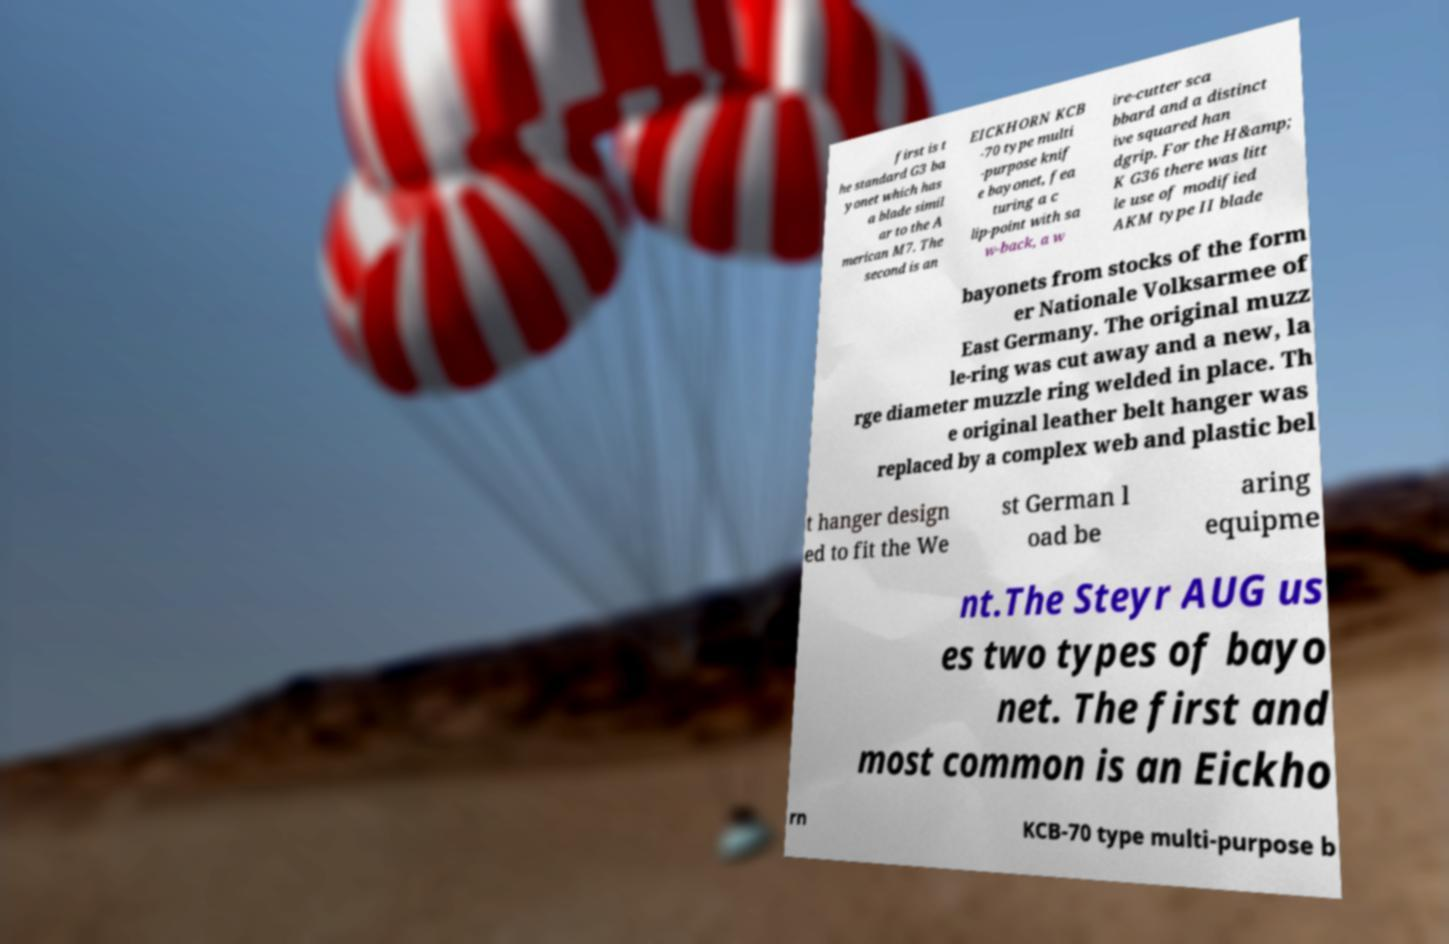Can you read and provide the text displayed in the image?This photo seems to have some interesting text. Can you extract and type it out for me? first is t he standard G3 ba yonet which has a blade simil ar to the A merican M7. The second is an EICKHORN KCB -70 type multi -purpose knif e bayonet, fea turing a c lip-point with sa w-back, a w ire-cutter sca bbard and a distinct ive squared han dgrip. For the H&amp; K G36 there was litt le use of modified AKM type II blade bayonets from stocks of the form er Nationale Volksarmee of East Germany. The original muzz le-ring was cut away and a new, la rge diameter muzzle ring welded in place. Th e original leather belt hanger was replaced by a complex web and plastic bel t hanger design ed to fit the We st German l oad be aring equipme nt.The Steyr AUG us es two types of bayo net. The first and most common is an Eickho rn KCB-70 type multi-purpose b 